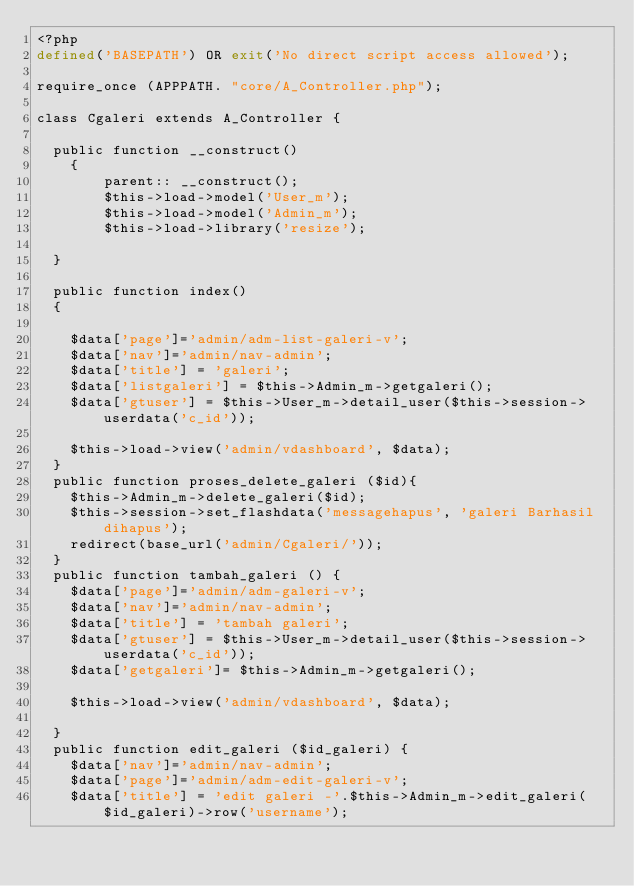Convert code to text. <code><loc_0><loc_0><loc_500><loc_500><_PHP_><?php
defined('BASEPATH') OR exit('No direct script access allowed');

require_once (APPPATH. "core/A_Controller.php");

class Cgaleri extends A_Controller {

	public function __construct()
    {
        parent:: __construct();
		    $this->load->model('User_m');
		    $this->load->model('Admin_m');
		    $this->load->library('resize');

	}

	public function index()
	{

		$data['page']='admin/adm-list-galeri-v';
		$data['nav']='admin/nav-admin';
		$data['title'] = 'galeri';
		$data['listgaleri'] = $this->Admin_m->getgaleri();
		$data['gtuser'] = $this->User_m->detail_user($this->session->userdata('c_id'));

		$this->load->view('admin/vdashboard', $data);
	}
	public function proses_delete_galeri ($id){
		$this->Admin_m->delete_galeri($id);
		$this->session->set_flashdata('messagehapus', 'galeri Barhasil dihapus');
		redirect(base_url('admin/Cgaleri/'));
	}
	public function tambah_galeri () {
		$data['page']='admin/adm-galeri-v';
		$data['nav']='admin/nav-admin';
		$data['title'] = 'tambah galeri';
		$data['gtuser'] = $this->User_m->detail_user($this->session->userdata('c_id'));
		$data['getgaleri']= $this->Admin_m->getgaleri();

		$this->load->view('admin/vdashboard', $data);

	}
	public function edit_galeri ($id_galeri) {
		$data['nav']='admin/nav-admin';
		$data['page']='admin/adm-edit-galeri-v';
		$data['title'] = 'edit galeri -'.$this->Admin_m->edit_galeri($id_galeri)->row('username');</code> 